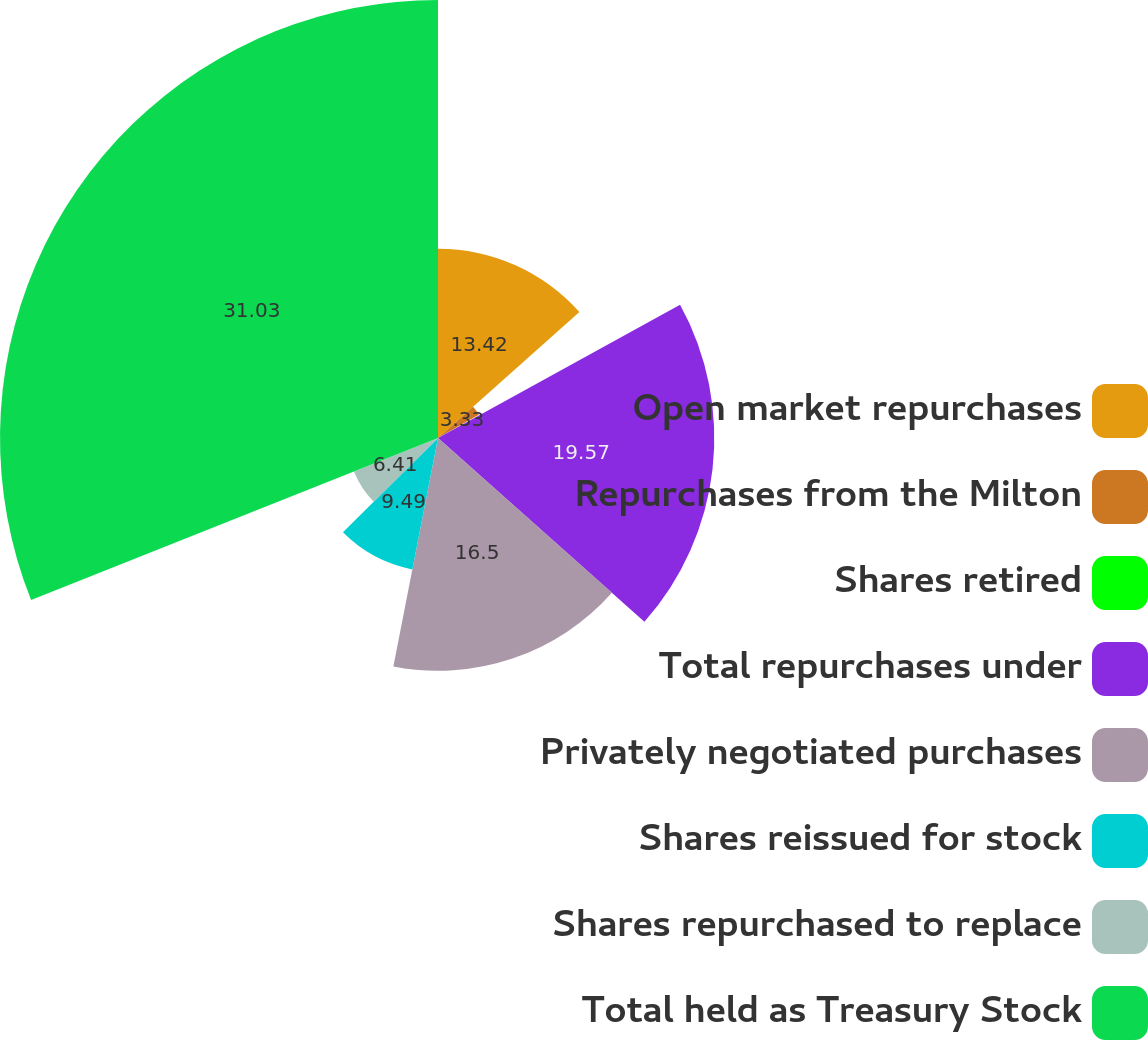<chart> <loc_0><loc_0><loc_500><loc_500><pie_chart><fcel>Open market repurchases<fcel>Repurchases from the Milton<fcel>Shares retired<fcel>Total repurchases under<fcel>Privately negotiated purchases<fcel>Shares reissued for stock<fcel>Shares repurchased to replace<fcel>Total held as Treasury Stock<nl><fcel>13.42%<fcel>3.33%<fcel>0.25%<fcel>19.58%<fcel>16.5%<fcel>9.49%<fcel>6.41%<fcel>31.04%<nl></chart> 